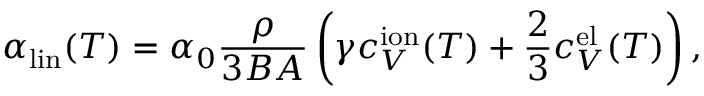Convert formula to latex. <formula><loc_0><loc_0><loc_500><loc_500>\alpha _ { l i n } ( T ) = \alpha _ { 0 } \frac { \rho } { 3 B A } \left ( \gamma c _ { V } ^ { i o n } ( T ) + \frac { 2 } { 3 } c _ { V } ^ { e l } ( T ) \right ) ,</formula> 